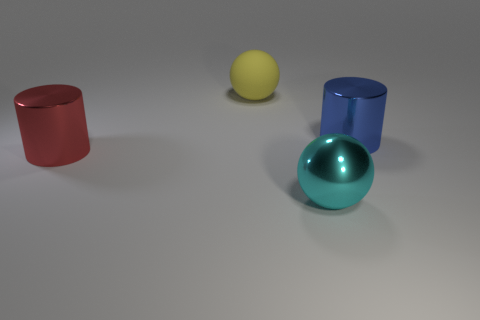How many other objects are there of the same shape as the big cyan thing?
Offer a very short reply. 1. What number of things are either shiny cylinders on the right side of the matte ball or cylinders that are behind the red shiny cylinder?
Provide a short and direct response. 1. How big is the shiny object that is both behind the cyan thing and on the left side of the blue metal object?
Your response must be concise. Large. There is a big metal object that is right of the big cyan shiny thing; is it the same shape as the cyan metallic thing?
Give a very brief answer. No. What is the size of the red cylinder in front of the yellow rubber ball that is to the left of the large object on the right side of the big cyan metallic object?
Your response must be concise. Large. How many things are purple rubber blocks or metallic objects?
Offer a terse response. 3. What is the shape of the large metal thing that is on the left side of the large blue cylinder and behind the cyan object?
Provide a succinct answer. Cylinder. There is a big cyan metal thing; is its shape the same as the big object on the left side of the matte ball?
Your answer should be very brief. No. There is a blue metal cylinder; are there any large balls to the left of it?
Keep it short and to the point. Yes. How many spheres are large matte things or tiny things?
Your response must be concise. 1. 